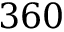<formula> <loc_0><loc_0><loc_500><loc_500>3 6 0</formula> 